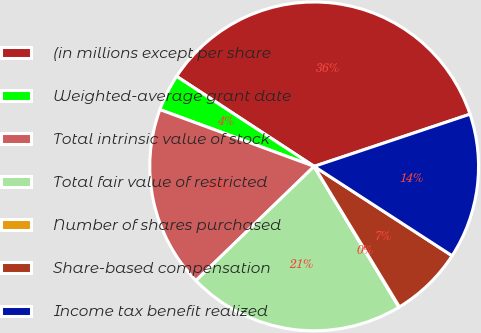Convert chart to OTSL. <chart><loc_0><loc_0><loc_500><loc_500><pie_chart><fcel>(in millions except per share<fcel>Weighted-average grant date<fcel>Total intrinsic value of stock<fcel>Total fair value of restricted<fcel>Number of shares purchased<fcel>Share-based compensation<fcel>Income tax benefit realized<nl><fcel>35.63%<fcel>3.61%<fcel>17.84%<fcel>21.4%<fcel>0.05%<fcel>7.17%<fcel>14.29%<nl></chart> 